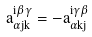<formula> <loc_0><loc_0><loc_500><loc_500>a ^ { i \beta \gamma } _ { \alpha j k } = - a ^ { i \gamma \beta } _ { \alpha k j }</formula> 